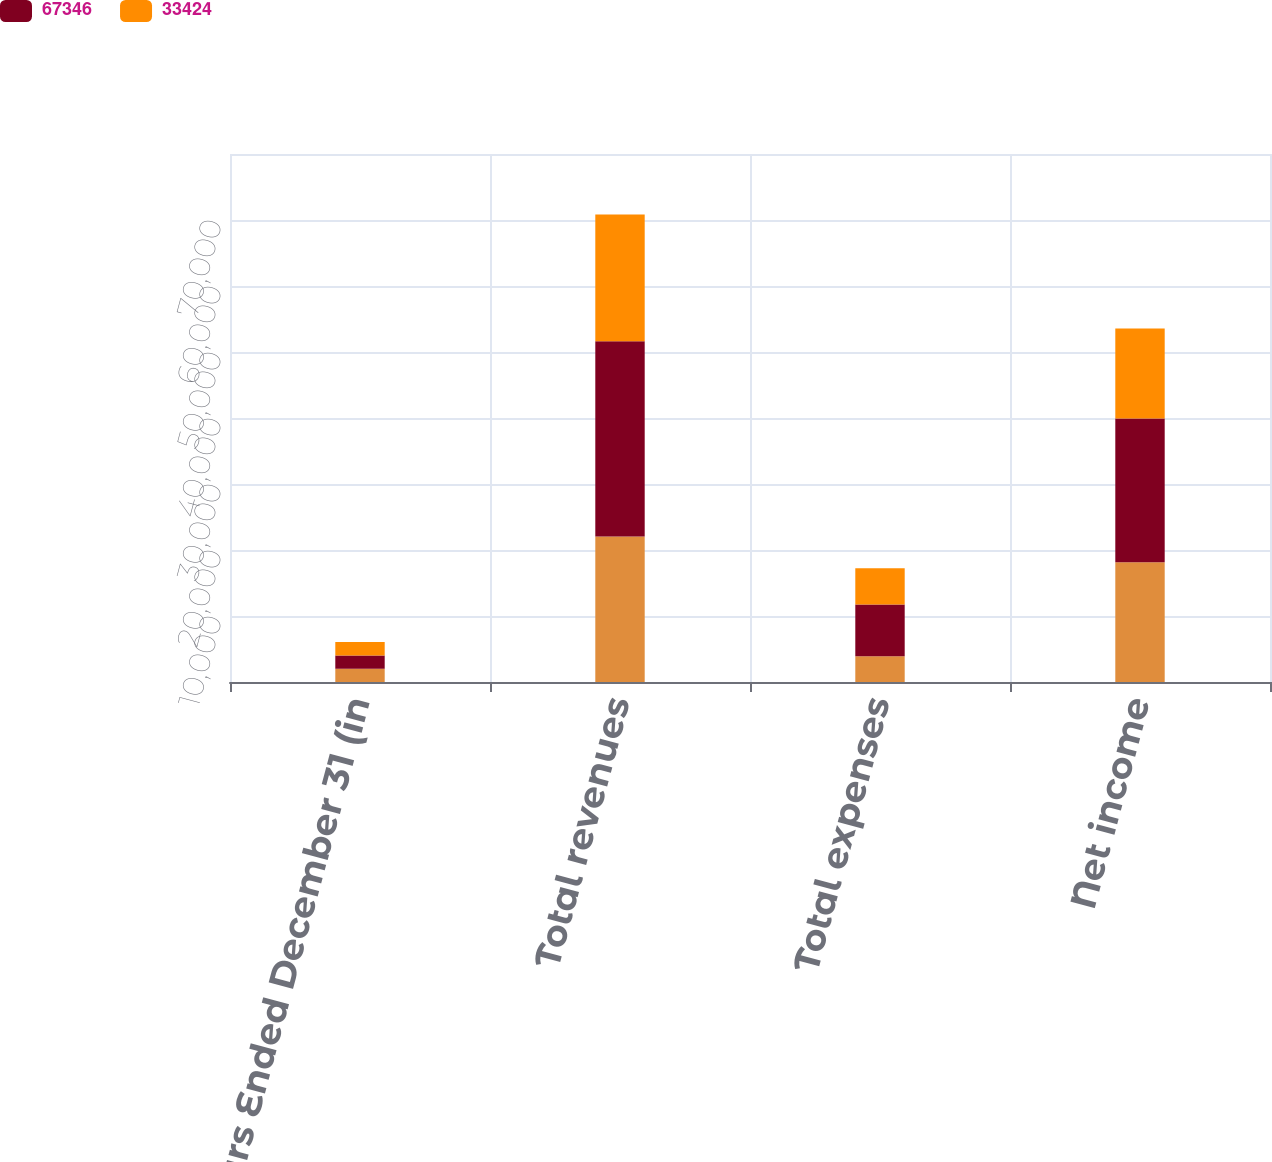<chart> <loc_0><loc_0><loc_500><loc_500><stacked_bar_chart><ecel><fcel>Years Ended December 31 (in<fcel>Total revenues<fcel>Total expenses<fcel>Net income<nl><fcel>nan<fcel>2015<fcel>22055<fcel>3898<fcel>18157<nl><fcel>67346<fcel>2014<fcel>29579<fcel>7828<fcel>21751<nl><fcel>33424<fcel>2013<fcel>19181<fcel>5515<fcel>13666<nl></chart> 